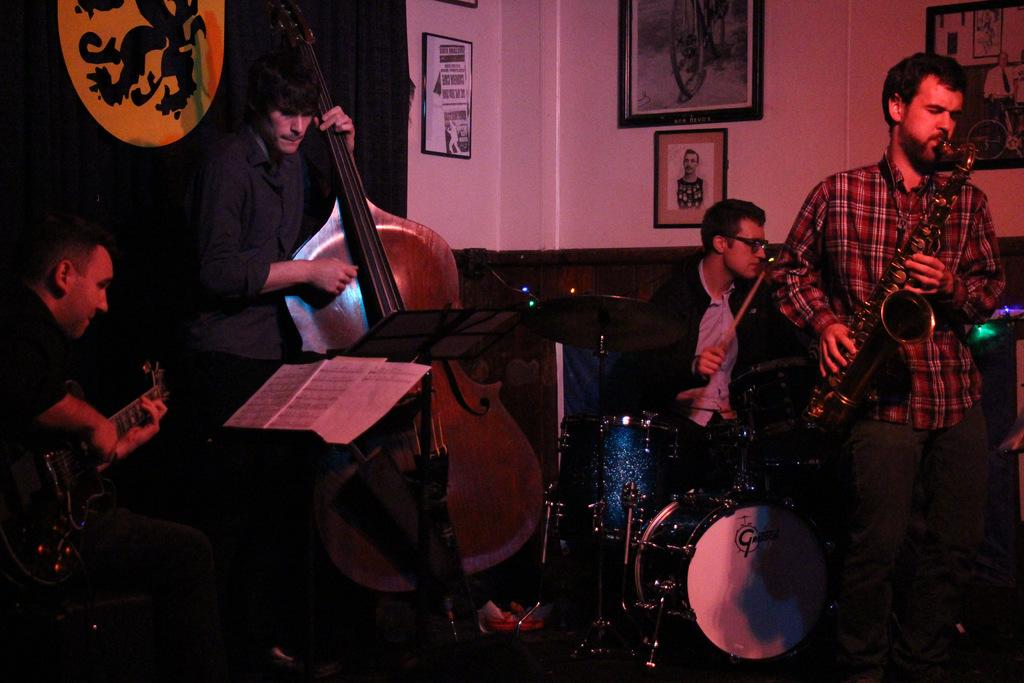How many people are in the image? There is a group of people in the image. What are the people in the image doing? The people are playing music. What type of boats can be seen in the image? There are no boats present in the image; it features a group of people playing music. What does the mother of the person playing the guitar say in the image? There is no mention of a mother or any spoken words in the image. 